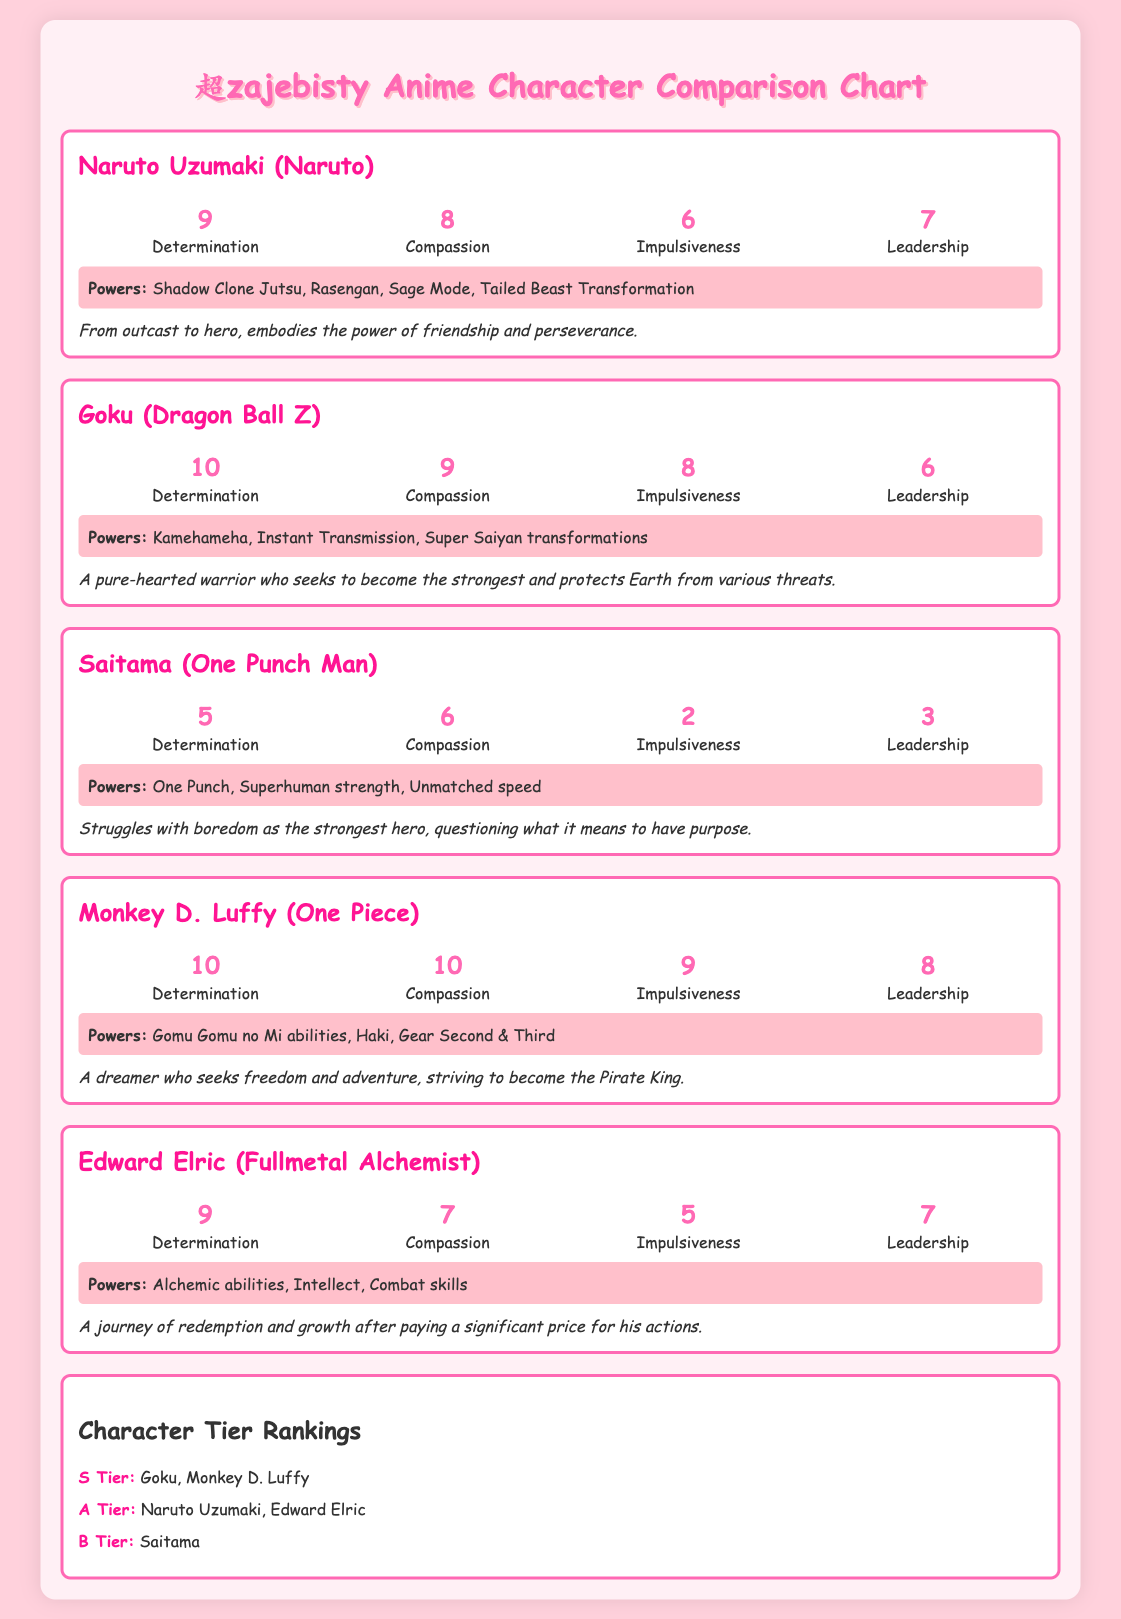What is the title of the chart? The title of the chart is clearly stated in the document as "超zajebisty Anime Character Comparison Chart".
Answer: 超zajebisty Anime Character Comparison Chart Who has the highest determination score? The character with the highest determination score is Goku with a score of 10.
Answer: Goku What is Saitama's impulsiveness score? Saitama's impulsiveness score is listed as 2 in the traits section.
Answer: 2 Which character's arc focuses on becoming the Pirate King? Monkey D. Luffy's arc focuses on striving to become the Pirate King.
Answer: Monkey D. Luffy In which tier is Edward Elric ranked? Edward Elric is ranked in the A Tier according to the tier rankings provided.
Answer: A Tier What powers does Naruto Uzumaki possess? Naruto's powers include Shadow Clone Jutsu, Rasengan, Sage Mode, and Tailed Beast Transformation.
Answer: Shadow Clone Jutsu, Rasengan, Sage Mode, Tailed Beast Transformation What is the visual element used to rank characters? The visual element used for ranking characters is a tier ranking system.
Answer: Tier ranking system How many traits are there for each character? Each character has four traits listed in the character section.
Answer: Four traits 